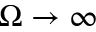<formula> <loc_0><loc_0><loc_500><loc_500>\Omega \to \infty</formula> 